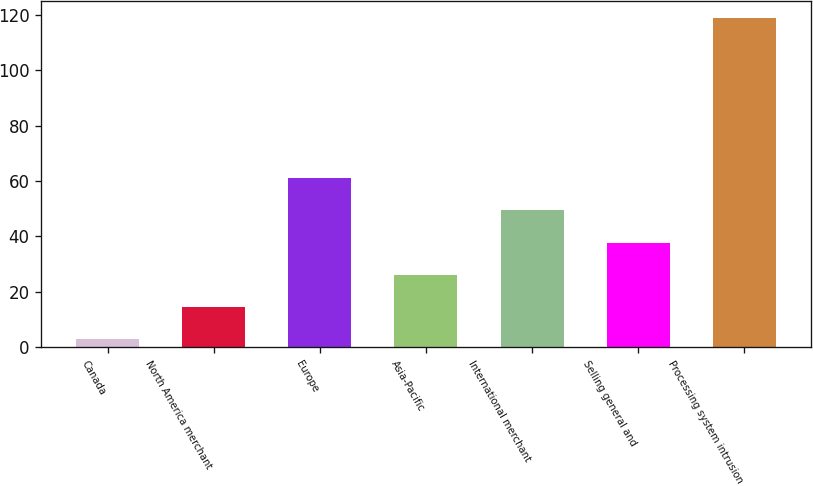Convert chart to OTSL. <chart><loc_0><loc_0><loc_500><loc_500><bar_chart><fcel>Canada<fcel>North America merchant<fcel>Europe<fcel>Asia-Pacific<fcel>International merchant<fcel>Selling general and<fcel>Processing system intrusion<nl><fcel>3<fcel>14.6<fcel>61<fcel>26.2<fcel>49.4<fcel>37.8<fcel>119<nl></chart> 